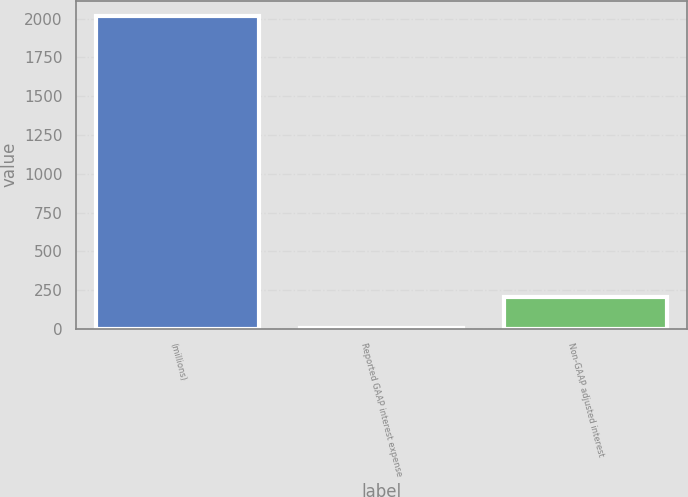Convert chart to OTSL. <chart><loc_0><loc_0><loc_500><loc_500><bar_chart><fcel>(millions)<fcel>Reported GAAP interest expense<fcel>Non-GAAP adjusted interest<nl><fcel>2015<fcel>5<fcel>206<nl></chart> 